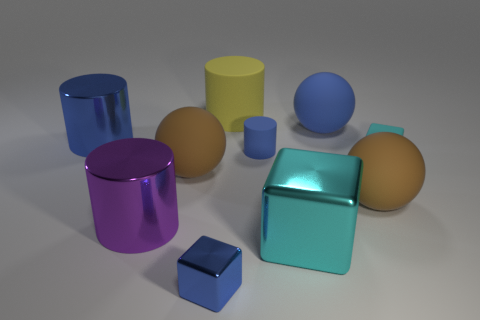There is a large rubber thing that is the same color as the tiny cylinder; what shape is it?
Your answer should be very brief. Sphere. Is the material of the big cube behind the blue metallic cube the same as the blue ball?
Provide a succinct answer. No. There is a big thing that is the same shape as the tiny cyan object; what is its color?
Give a very brief answer. Cyan. Is there anything else that has the same shape as the big cyan object?
Offer a terse response. Yes. Are there an equal number of big cyan cubes that are left of the big cyan metal thing and big yellow rubber cylinders?
Offer a very short reply. No. There is a small blue rubber object; are there any big brown spheres on the left side of it?
Provide a succinct answer. Yes. There is a cylinder right of the object that is behind the sphere that is behind the tiny rubber block; what size is it?
Ensure brevity in your answer.  Small. There is a big brown rubber object that is left of the blue matte ball; does it have the same shape as the blue metallic thing that is behind the small cyan thing?
Offer a terse response. No. What size is the blue matte object that is the same shape as the purple metal object?
Ensure brevity in your answer.  Small. How many yellow objects are the same material as the small cylinder?
Your answer should be very brief. 1. 